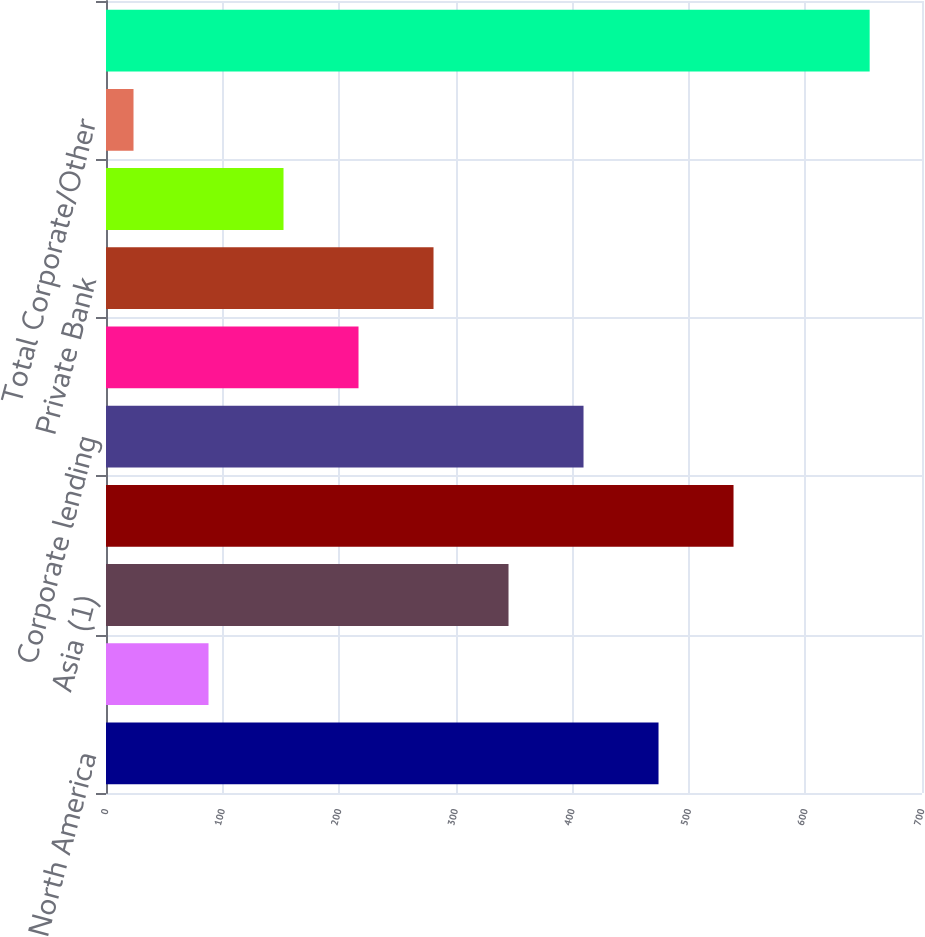Convert chart to OTSL. <chart><loc_0><loc_0><loc_500><loc_500><bar_chart><fcel>North America<fcel>Latin America<fcel>Asia (1)<fcel>Total<fcel>Corporate lending<fcel>Treasury and trade solutions<fcel>Private Bank<fcel>Markets and securities<fcel>Total Corporate/Other<fcel>Total Citigroup loans (AVG)<nl><fcel>473.98<fcel>87.94<fcel>345.3<fcel>538.32<fcel>409.64<fcel>216.62<fcel>280.96<fcel>152.28<fcel>23.6<fcel>655.1<nl></chart> 